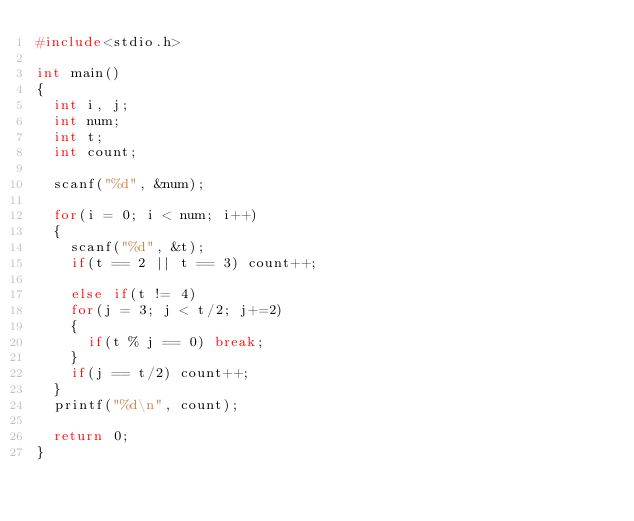Convert code to text. <code><loc_0><loc_0><loc_500><loc_500><_C_>#include<stdio.h>

int main()
{
	int i, j;
	int num;
	int t;
	int count;
	
	scanf("%d", &num);
	
	for(i = 0; i < num; i++)
	{
		scanf("%d", &t);
		if(t == 2 || t == 3) count++;

		else if(t != 4)
		for(j = 3; j < t/2; j+=2)
		{
			if(t % j == 0) break;
		}
		if(j == t/2) count++;
	}
	printf("%d\n", count);
	
	return 0;
}</code> 